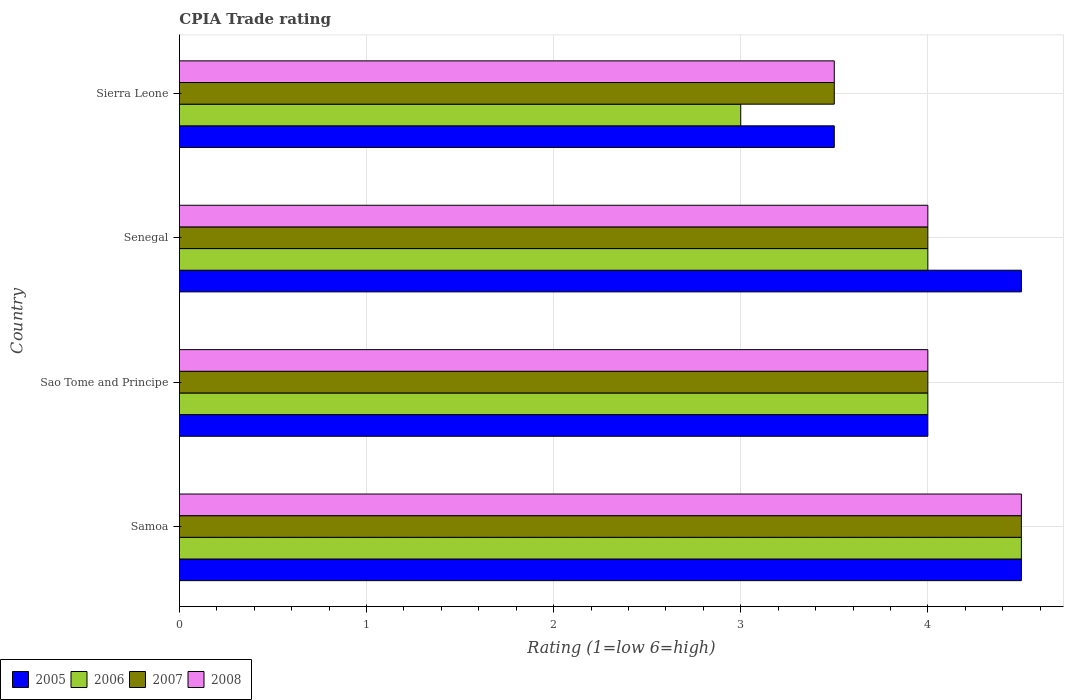How many groups of bars are there?
Your answer should be compact. 4. Are the number of bars per tick equal to the number of legend labels?
Give a very brief answer. Yes. How many bars are there on the 4th tick from the top?
Your response must be concise. 4. What is the label of the 1st group of bars from the top?
Your answer should be compact. Sierra Leone. Across all countries, what is the maximum CPIA rating in 2006?
Offer a very short reply. 4.5. Across all countries, what is the minimum CPIA rating in 2006?
Provide a short and direct response. 3. In which country was the CPIA rating in 2005 maximum?
Your response must be concise. Samoa. In which country was the CPIA rating in 2008 minimum?
Your answer should be very brief. Sierra Leone. What is the total CPIA rating in 2005 in the graph?
Keep it short and to the point. 16.5. What is the difference between the CPIA rating in 2008 in Sierra Leone and the CPIA rating in 2005 in Samoa?
Your response must be concise. -1. What is the ratio of the CPIA rating in 2005 in Sao Tome and Principe to that in Sierra Leone?
Provide a succinct answer. 1.14. Is the CPIA rating in 2008 in Sao Tome and Principe less than that in Senegal?
Offer a terse response. No. Is the difference between the CPIA rating in 2005 in Senegal and Sierra Leone greater than the difference between the CPIA rating in 2008 in Senegal and Sierra Leone?
Your answer should be compact. Yes. What is the difference between the highest and the second highest CPIA rating in 2008?
Your response must be concise. 0.5. What is the difference between the highest and the lowest CPIA rating in 2007?
Ensure brevity in your answer.  1. Is the sum of the CPIA rating in 2008 in Sao Tome and Principe and Sierra Leone greater than the maximum CPIA rating in 2006 across all countries?
Provide a short and direct response. Yes. Is it the case that in every country, the sum of the CPIA rating in 2006 and CPIA rating in 2008 is greater than the sum of CPIA rating in 2007 and CPIA rating in 2005?
Provide a short and direct response. No. What does the 4th bar from the top in Samoa represents?
Make the answer very short. 2005. How many legend labels are there?
Provide a succinct answer. 4. How are the legend labels stacked?
Offer a very short reply. Horizontal. What is the title of the graph?
Your answer should be compact. CPIA Trade rating. Does "1969" appear as one of the legend labels in the graph?
Make the answer very short. No. What is the label or title of the Y-axis?
Keep it short and to the point. Country. What is the Rating (1=low 6=high) in 2005 in Samoa?
Ensure brevity in your answer.  4.5. What is the Rating (1=low 6=high) in 2006 in Samoa?
Make the answer very short. 4.5. What is the Rating (1=low 6=high) in 2007 in Samoa?
Make the answer very short. 4.5. What is the Rating (1=low 6=high) of 2008 in Samoa?
Your answer should be very brief. 4.5. What is the Rating (1=low 6=high) in 2008 in Sao Tome and Principe?
Provide a short and direct response. 4. What is the Rating (1=low 6=high) of 2005 in Senegal?
Provide a short and direct response. 4.5. What is the Rating (1=low 6=high) in 2006 in Senegal?
Your answer should be very brief. 4. What is the Rating (1=low 6=high) of 2008 in Senegal?
Make the answer very short. 4. What is the Rating (1=low 6=high) of 2005 in Sierra Leone?
Offer a very short reply. 3.5. What is the Rating (1=low 6=high) of 2006 in Sierra Leone?
Your answer should be compact. 3. What is the Rating (1=low 6=high) in 2008 in Sierra Leone?
Your answer should be compact. 3.5. Across all countries, what is the maximum Rating (1=low 6=high) of 2005?
Give a very brief answer. 4.5. Across all countries, what is the maximum Rating (1=low 6=high) of 2006?
Offer a very short reply. 4.5. Across all countries, what is the maximum Rating (1=low 6=high) in 2007?
Offer a terse response. 4.5. Across all countries, what is the maximum Rating (1=low 6=high) in 2008?
Offer a very short reply. 4.5. Across all countries, what is the minimum Rating (1=low 6=high) in 2006?
Your answer should be compact. 3. Across all countries, what is the minimum Rating (1=low 6=high) in 2007?
Offer a very short reply. 3.5. Across all countries, what is the minimum Rating (1=low 6=high) of 2008?
Provide a succinct answer. 3.5. What is the total Rating (1=low 6=high) of 2005 in the graph?
Keep it short and to the point. 16.5. What is the total Rating (1=low 6=high) in 2007 in the graph?
Ensure brevity in your answer.  16. What is the total Rating (1=low 6=high) of 2008 in the graph?
Your answer should be very brief. 16. What is the difference between the Rating (1=low 6=high) of 2005 in Samoa and that in Sao Tome and Principe?
Offer a very short reply. 0.5. What is the difference between the Rating (1=low 6=high) in 2007 in Samoa and that in Sao Tome and Principe?
Give a very brief answer. 0.5. What is the difference between the Rating (1=low 6=high) of 2005 in Samoa and that in Senegal?
Provide a short and direct response. 0. What is the difference between the Rating (1=low 6=high) of 2006 in Samoa and that in Sierra Leone?
Offer a terse response. 1.5. What is the difference between the Rating (1=low 6=high) of 2007 in Sao Tome and Principe and that in Senegal?
Keep it short and to the point. 0. What is the difference between the Rating (1=low 6=high) of 2008 in Sao Tome and Principe and that in Senegal?
Offer a terse response. 0. What is the difference between the Rating (1=low 6=high) of 2007 in Sao Tome and Principe and that in Sierra Leone?
Your answer should be compact. 0.5. What is the difference between the Rating (1=low 6=high) of 2008 in Senegal and that in Sierra Leone?
Provide a succinct answer. 0.5. What is the difference between the Rating (1=low 6=high) of 2006 in Samoa and the Rating (1=low 6=high) of 2007 in Sao Tome and Principe?
Provide a short and direct response. 0.5. What is the difference between the Rating (1=low 6=high) of 2007 in Samoa and the Rating (1=low 6=high) of 2008 in Sao Tome and Principe?
Keep it short and to the point. 0.5. What is the difference between the Rating (1=low 6=high) in 2005 in Samoa and the Rating (1=low 6=high) in 2006 in Senegal?
Provide a short and direct response. 0.5. What is the difference between the Rating (1=low 6=high) of 2005 in Samoa and the Rating (1=low 6=high) of 2007 in Senegal?
Give a very brief answer. 0.5. What is the difference between the Rating (1=low 6=high) in 2005 in Samoa and the Rating (1=low 6=high) in 2008 in Senegal?
Give a very brief answer. 0.5. What is the difference between the Rating (1=low 6=high) of 2006 in Samoa and the Rating (1=low 6=high) of 2007 in Senegal?
Your response must be concise. 0.5. What is the difference between the Rating (1=low 6=high) of 2006 in Samoa and the Rating (1=low 6=high) of 2008 in Senegal?
Your answer should be very brief. 0.5. What is the difference between the Rating (1=low 6=high) in 2007 in Samoa and the Rating (1=low 6=high) in 2008 in Senegal?
Your response must be concise. 0.5. What is the difference between the Rating (1=low 6=high) in 2005 in Samoa and the Rating (1=low 6=high) in 2007 in Sierra Leone?
Offer a very short reply. 1. What is the difference between the Rating (1=low 6=high) in 2006 in Samoa and the Rating (1=low 6=high) in 2007 in Sierra Leone?
Provide a short and direct response. 1. What is the difference between the Rating (1=low 6=high) of 2007 in Samoa and the Rating (1=low 6=high) of 2008 in Sierra Leone?
Keep it short and to the point. 1. What is the difference between the Rating (1=low 6=high) of 2005 in Sao Tome and Principe and the Rating (1=low 6=high) of 2006 in Senegal?
Give a very brief answer. 0. What is the difference between the Rating (1=low 6=high) in 2006 in Sao Tome and Principe and the Rating (1=low 6=high) in 2007 in Senegal?
Make the answer very short. 0. What is the difference between the Rating (1=low 6=high) in 2006 in Sao Tome and Principe and the Rating (1=low 6=high) in 2008 in Senegal?
Your answer should be very brief. 0. What is the difference between the Rating (1=low 6=high) in 2005 in Sao Tome and Principe and the Rating (1=low 6=high) in 2006 in Sierra Leone?
Give a very brief answer. 1. What is the difference between the Rating (1=low 6=high) in 2005 in Sao Tome and Principe and the Rating (1=low 6=high) in 2008 in Sierra Leone?
Ensure brevity in your answer.  0.5. What is the difference between the Rating (1=low 6=high) in 2006 in Sao Tome and Principe and the Rating (1=low 6=high) in 2007 in Sierra Leone?
Keep it short and to the point. 0.5. What is the difference between the Rating (1=low 6=high) in 2005 in Senegal and the Rating (1=low 6=high) in 2006 in Sierra Leone?
Make the answer very short. 1.5. What is the difference between the Rating (1=low 6=high) in 2005 in Senegal and the Rating (1=low 6=high) in 2007 in Sierra Leone?
Your answer should be very brief. 1. What is the difference between the Rating (1=low 6=high) in 2005 in Senegal and the Rating (1=low 6=high) in 2008 in Sierra Leone?
Make the answer very short. 1. What is the difference between the Rating (1=low 6=high) of 2006 in Senegal and the Rating (1=low 6=high) of 2008 in Sierra Leone?
Offer a terse response. 0.5. What is the difference between the Rating (1=low 6=high) in 2007 in Senegal and the Rating (1=low 6=high) in 2008 in Sierra Leone?
Provide a short and direct response. 0.5. What is the average Rating (1=low 6=high) of 2005 per country?
Make the answer very short. 4.12. What is the average Rating (1=low 6=high) of 2006 per country?
Your answer should be very brief. 3.88. What is the average Rating (1=low 6=high) of 2008 per country?
Your answer should be compact. 4. What is the difference between the Rating (1=low 6=high) of 2005 and Rating (1=low 6=high) of 2006 in Samoa?
Your answer should be compact. 0. What is the difference between the Rating (1=low 6=high) of 2005 and Rating (1=low 6=high) of 2008 in Samoa?
Your response must be concise. 0. What is the difference between the Rating (1=low 6=high) of 2006 and Rating (1=low 6=high) of 2008 in Samoa?
Your answer should be very brief. 0. What is the difference between the Rating (1=low 6=high) of 2005 and Rating (1=low 6=high) of 2006 in Sao Tome and Principe?
Ensure brevity in your answer.  0. What is the difference between the Rating (1=low 6=high) in 2006 and Rating (1=low 6=high) in 2007 in Sao Tome and Principe?
Make the answer very short. 0. What is the difference between the Rating (1=low 6=high) in 2007 and Rating (1=low 6=high) in 2008 in Sao Tome and Principe?
Give a very brief answer. 0. What is the difference between the Rating (1=low 6=high) in 2005 and Rating (1=low 6=high) in 2007 in Senegal?
Offer a very short reply. 0.5. What is the difference between the Rating (1=low 6=high) in 2005 and Rating (1=low 6=high) in 2008 in Senegal?
Keep it short and to the point. 0.5. What is the difference between the Rating (1=low 6=high) of 2005 and Rating (1=low 6=high) of 2006 in Sierra Leone?
Offer a terse response. 0.5. What is the difference between the Rating (1=low 6=high) of 2005 and Rating (1=low 6=high) of 2007 in Sierra Leone?
Make the answer very short. 0. What is the difference between the Rating (1=low 6=high) in 2005 and Rating (1=low 6=high) in 2008 in Sierra Leone?
Offer a terse response. 0. What is the difference between the Rating (1=low 6=high) of 2006 and Rating (1=low 6=high) of 2007 in Sierra Leone?
Offer a very short reply. -0.5. What is the difference between the Rating (1=low 6=high) of 2006 and Rating (1=low 6=high) of 2008 in Sierra Leone?
Provide a short and direct response. -0.5. What is the ratio of the Rating (1=low 6=high) of 2005 in Samoa to that in Sao Tome and Principe?
Give a very brief answer. 1.12. What is the ratio of the Rating (1=low 6=high) in 2006 in Samoa to that in Sao Tome and Principe?
Provide a short and direct response. 1.12. What is the ratio of the Rating (1=low 6=high) of 2007 in Samoa to that in Sao Tome and Principe?
Offer a very short reply. 1.12. What is the ratio of the Rating (1=low 6=high) of 2005 in Samoa to that in Senegal?
Your answer should be compact. 1. What is the ratio of the Rating (1=low 6=high) in 2005 in Samoa to that in Sierra Leone?
Your response must be concise. 1.29. What is the ratio of the Rating (1=low 6=high) of 2007 in Samoa to that in Sierra Leone?
Your response must be concise. 1.29. What is the ratio of the Rating (1=low 6=high) in 2008 in Samoa to that in Sierra Leone?
Your answer should be compact. 1.29. What is the ratio of the Rating (1=low 6=high) of 2005 in Sao Tome and Principe to that in Senegal?
Keep it short and to the point. 0.89. What is the ratio of the Rating (1=low 6=high) in 2006 in Sao Tome and Principe to that in Senegal?
Your answer should be compact. 1. What is the ratio of the Rating (1=low 6=high) of 2007 in Sao Tome and Principe to that in Senegal?
Provide a short and direct response. 1. What is the ratio of the Rating (1=low 6=high) in 2008 in Sao Tome and Principe to that in Senegal?
Ensure brevity in your answer.  1. What is the ratio of the Rating (1=low 6=high) of 2005 in Sao Tome and Principe to that in Sierra Leone?
Provide a succinct answer. 1.14. What is the ratio of the Rating (1=low 6=high) in 2006 in Senegal to that in Sierra Leone?
Offer a very short reply. 1.33. What is the ratio of the Rating (1=low 6=high) of 2007 in Senegal to that in Sierra Leone?
Ensure brevity in your answer.  1.14. What is the ratio of the Rating (1=low 6=high) of 2008 in Senegal to that in Sierra Leone?
Your response must be concise. 1.14. What is the difference between the highest and the second highest Rating (1=low 6=high) of 2005?
Ensure brevity in your answer.  0. What is the difference between the highest and the second highest Rating (1=low 6=high) in 2006?
Ensure brevity in your answer.  0.5. What is the difference between the highest and the second highest Rating (1=low 6=high) of 2007?
Your answer should be compact. 0.5. What is the difference between the highest and the second highest Rating (1=low 6=high) of 2008?
Offer a terse response. 0.5. What is the difference between the highest and the lowest Rating (1=low 6=high) of 2007?
Make the answer very short. 1. 